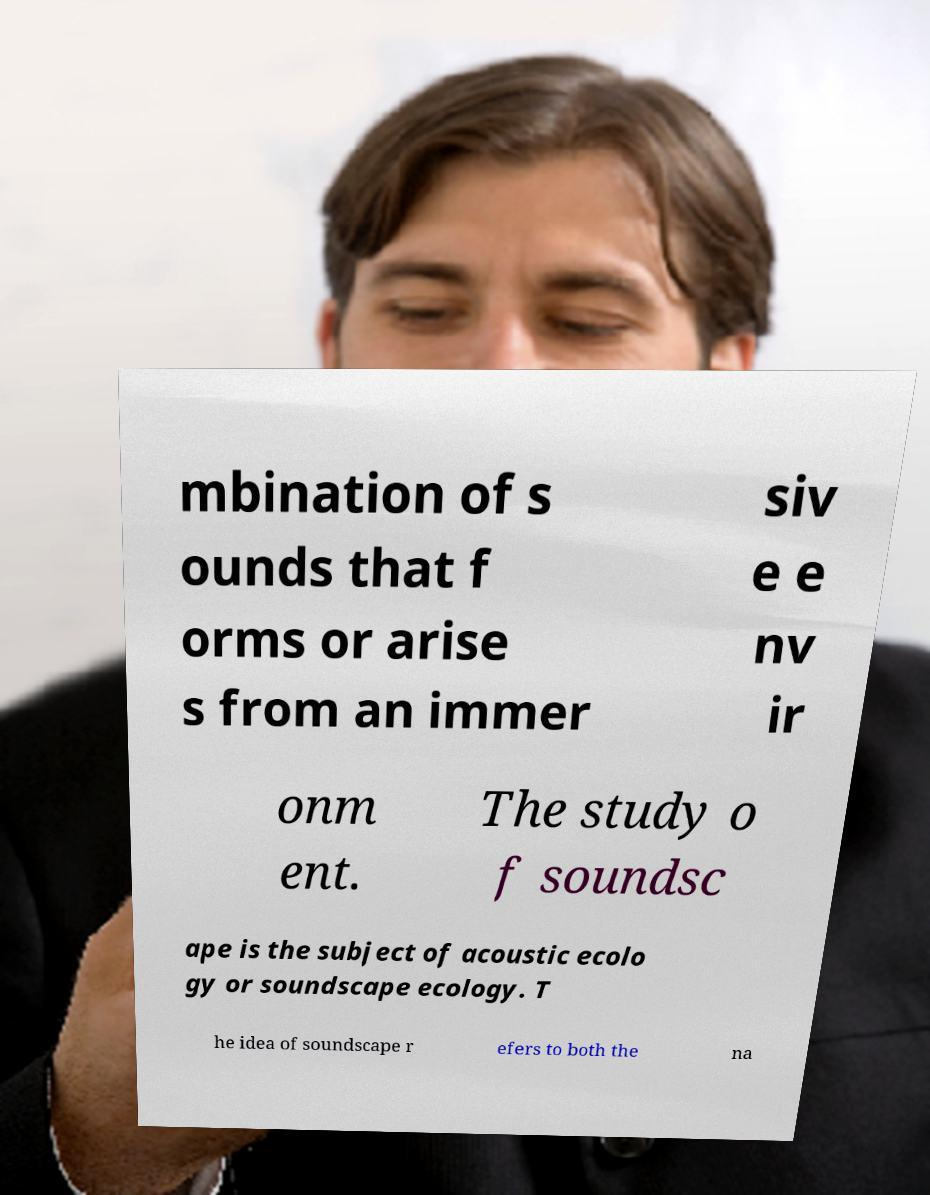I need the written content from this picture converted into text. Can you do that? mbination of s ounds that f orms or arise s from an immer siv e e nv ir onm ent. The study o f soundsc ape is the subject of acoustic ecolo gy or soundscape ecology. T he idea of soundscape r efers to both the na 